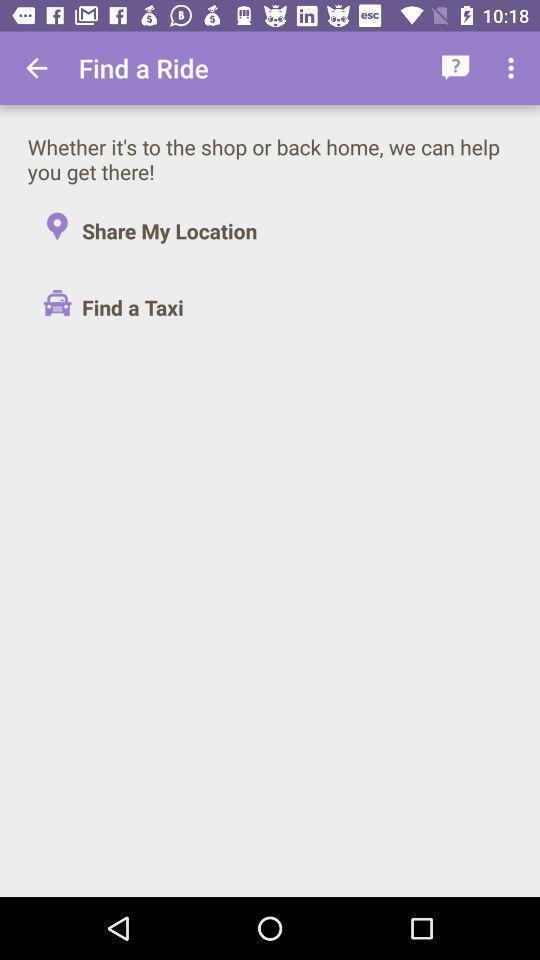Give me a summary of this screen capture. Screen showing find a ride. 